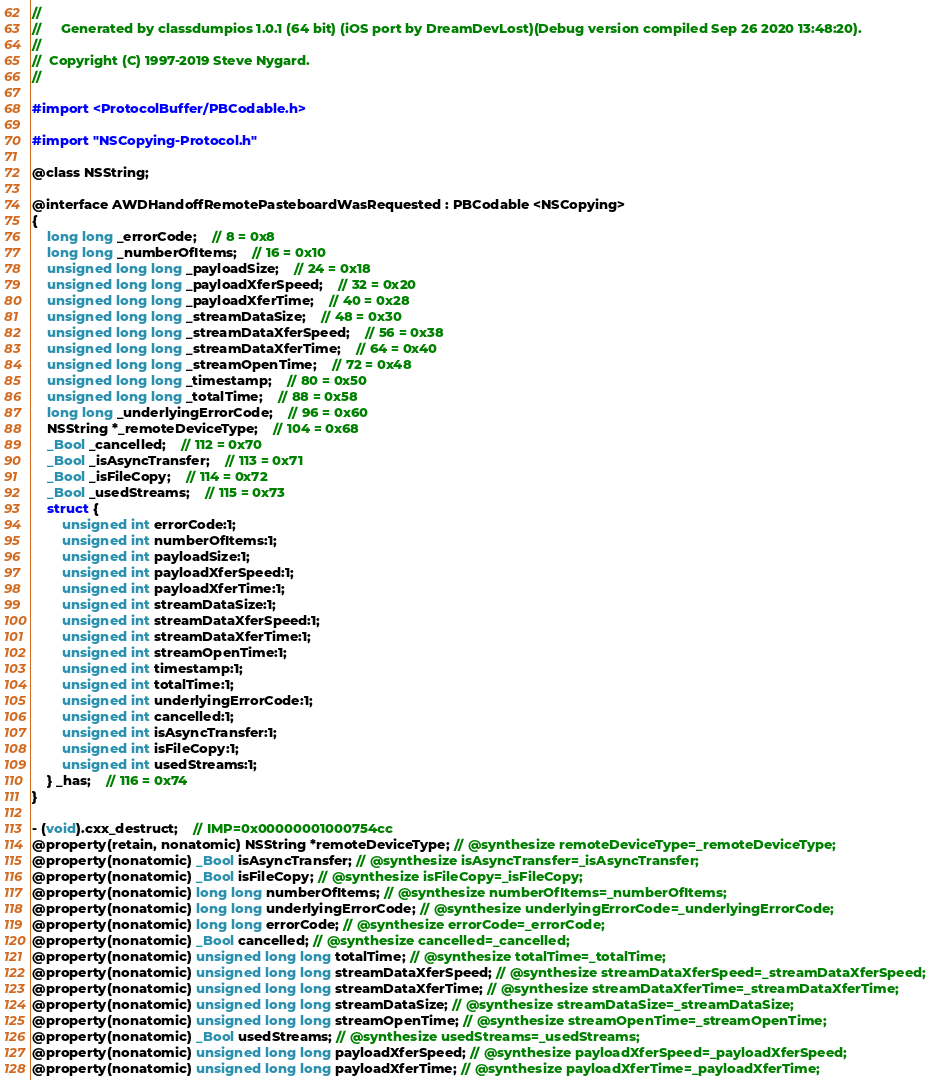Convert code to text. <code><loc_0><loc_0><loc_500><loc_500><_C_>//
//     Generated by classdumpios 1.0.1 (64 bit) (iOS port by DreamDevLost)(Debug version compiled Sep 26 2020 13:48:20).
//
//  Copyright (C) 1997-2019 Steve Nygard.
//

#import <ProtocolBuffer/PBCodable.h>

#import "NSCopying-Protocol.h"

@class NSString;

@interface AWDHandoffRemotePasteboardWasRequested : PBCodable <NSCopying>
{
    long long _errorCode;	// 8 = 0x8
    long long _numberOfItems;	// 16 = 0x10
    unsigned long long _payloadSize;	// 24 = 0x18
    unsigned long long _payloadXferSpeed;	// 32 = 0x20
    unsigned long long _payloadXferTime;	// 40 = 0x28
    unsigned long long _streamDataSize;	// 48 = 0x30
    unsigned long long _streamDataXferSpeed;	// 56 = 0x38
    unsigned long long _streamDataXferTime;	// 64 = 0x40
    unsigned long long _streamOpenTime;	// 72 = 0x48
    unsigned long long _timestamp;	// 80 = 0x50
    unsigned long long _totalTime;	// 88 = 0x58
    long long _underlyingErrorCode;	// 96 = 0x60
    NSString *_remoteDeviceType;	// 104 = 0x68
    _Bool _cancelled;	// 112 = 0x70
    _Bool _isAsyncTransfer;	// 113 = 0x71
    _Bool _isFileCopy;	// 114 = 0x72
    _Bool _usedStreams;	// 115 = 0x73
    struct {
        unsigned int errorCode:1;
        unsigned int numberOfItems:1;
        unsigned int payloadSize:1;
        unsigned int payloadXferSpeed:1;
        unsigned int payloadXferTime:1;
        unsigned int streamDataSize:1;
        unsigned int streamDataXferSpeed:1;
        unsigned int streamDataXferTime:1;
        unsigned int streamOpenTime:1;
        unsigned int timestamp:1;
        unsigned int totalTime:1;
        unsigned int underlyingErrorCode:1;
        unsigned int cancelled:1;
        unsigned int isAsyncTransfer:1;
        unsigned int isFileCopy:1;
        unsigned int usedStreams:1;
    } _has;	// 116 = 0x74
}

- (void).cxx_destruct;	// IMP=0x00000001000754cc
@property(retain, nonatomic) NSString *remoteDeviceType; // @synthesize remoteDeviceType=_remoteDeviceType;
@property(nonatomic) _Bool isAsyncTransfer; // @synthesize isAsyncTransfer=_isAsyncTransfer;
@property(nonatomic) _Bool isFileCopy; // @synthesize isFileCopy=_isFileCopy;
@property(nonatomic) long long numberOfItems; // @synthesize numberOfItems=_numberOfItems;
@property(nonatomic) long long underlyingErrorCode; // @synthesize underlyingErrorCode=_underlyingErrorCode;
@property(nonatomic) long long errorCode; // @synthesize errorCode=_errorCode;
@property(nonatomic) _Bool cancelled; // @synthesize cancelled=_cancelled;
@property(nonatomic) unsigned long long totalTime; // @synthesize totalTime=_totalTime;
@property(nonatomic) unsigned long long streamDataXferSpeed; // @synthesize streamDataXferSpeed=_streamDataXferSpeed;
@property(nonatomic) unsigned long long streamDataXferTime; // @synthesize streamDataXferTime=_streamDataXferTime;
@property(nonatomic) unsigned long long streamDataSize; // @synthesize streamDataSize=_streamDataSize;
@property(nonatomic) unsigned long long streamOpenTime; // @synthesize streamOpenTime=_streamOpenTime;
@property(nonatomic) _Bool usedStreams; // @synthesize usedStreams=_usedStreams;
@property(nonatomic) unsigned long long payloadXferSpeed; // @synthesize payloadXferSpeed=_payloadXferSpeed;
@property(nonatomic) unsigned long long payloadXferTime; // @synthesize payloadXferTime=_payloadXferTime;</code> 